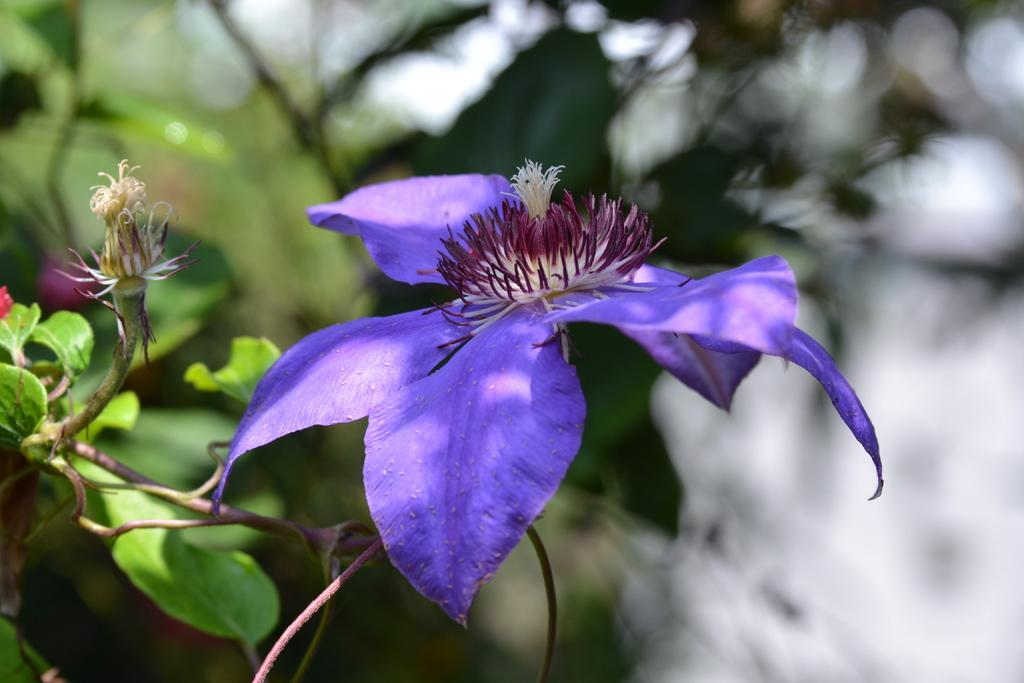What type of living organisms can be seen in the image? Flowers and plants are visible in the image. Can you describe the plants in the image? The plants in the image are not specified, but they are present alongside the flowers. What type of humor can be seen in the image? There is no humor present in the image; it features flowers and plants. What selection of ideas is depicted in the image? The image does not depict any ideas; it features flowers and plants. 